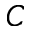<formula> <loc_0><loc_0><loc_500><loc_500>C</formula> 